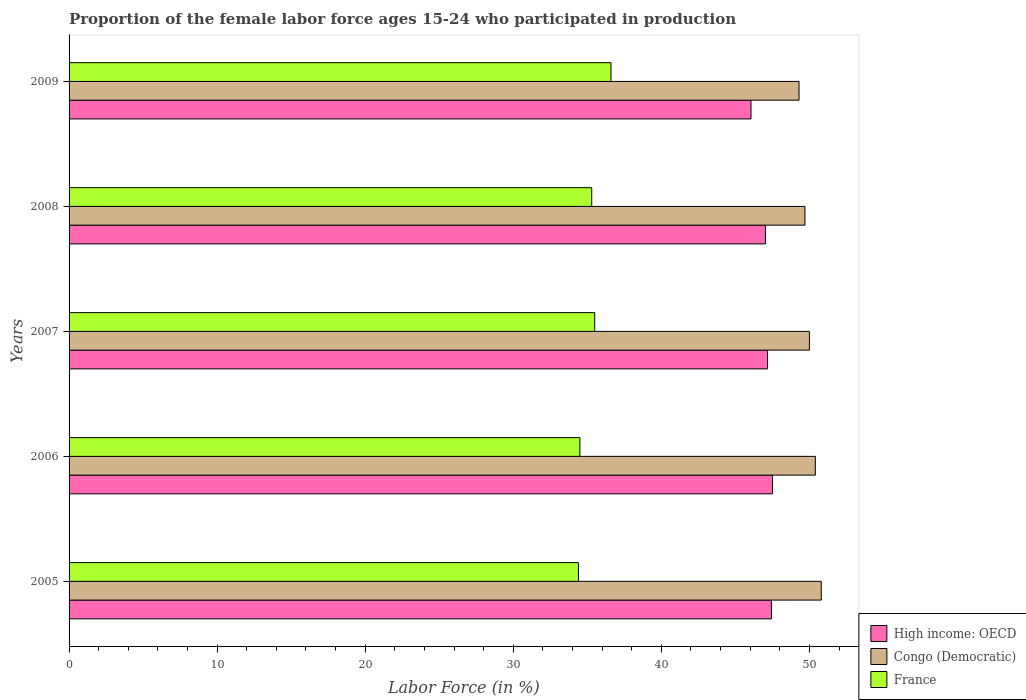How many different coloured bars are there?
Make the answer very short. 3. Are the number of bars per tick equal to the number of legend labels?
Give a very brief answer. Yes. How many bars are there on the 3rd tick from the top?
Provide a short and direct response. 3. How many bars are there on the 5th tick from the bottom?
Keep it short and to the point. 3. What is the label of the 1st group of bars from the top?
Provide a succinct answer. 2009. What is the proportion of the female labor force who participated in production in France in 2005?
Keep it short and to the point. 34.4. Across all years, what is the maximum proportion of the female labor force who participated in production in Congo (Democratic)?
Your answer should be compact. 50.8. Across all years, what is the minimum proportion of the female labor force who participated in production in Congo (Democratic)?
Provide a short and direct response. 49.3. In which year was the proportion of the female labor force who participated in production in France minimum?
Ensure brevity in your answer.  2005. What is the total proportion of the female labor force who participated in production in France in the graph?
Ensure brevity in your answer.  176.3. What is the difference between the proportion of the female labor force who participated in production in France in 2005 and that in 2009?
Your answer should be compact. -2.2. What is the difference between the proportion of the female labor force who participated in production in High income: OECD in 2006 and the proportion of the female labor force who participated in production in Congo (Democratic) in 2007?
Provide a short and direct response. -2.49. What is the average proportion of the female labor force who participated in production in High income: OECD per year?
Give a very brief answer. 47.04. In the year 2008, what is the difference between the proportion of the female labor force who participated in production in Congo (Democratic) and proportion of the female labor force who participated in production in France?
Your response must be concise. 14.4. In how many years, is the proportion of the female labor force who participated in production in Congo (Democratic) greater than 16 %?
Provide a succinct answer. 5. What is the ratio of the proportion of the female labor force who participated in production in Congo (Democratic) in 2007 to that in 2008?
Provide a short and direct response. 1.01. Is the proportion of the female labor force who participated in production in Congo (Democratic) in 2007 less than that in 2008?
Make the answer very short. No. What is the difference between the highest and the second highest proportion of the female labor force who participated in production in France?
Offer a terse response. 1.1. What is the difference between the highest and the lowest proportion of the female labor force who participated in production in High income: OECD?
Provide a succinct answer. 1.45. What does the 3rd bar from the bottom in 2006 represents?
Offer a very short reply. France. Are all the bars in the graph horizontal?
Make the answer very short. Yes. How many years are there in the graph?
Ensure brevity in your answer.  5. Where does the legend appear in the graph?
Your answer should be very brief. Bottom right. How many legend labels are there?
Your answer should be very brief. 3. How are the legend labels stacked?
Offer a terse response. Vertical. What is the title of the graph?
Keep it short and to the point. Proportion of the female labor force ages 15-24 who participated in production. Does "Singapore" appear as one of the legend labels in the graph?
Your response must be concise. No. What is the Labor Force (in %) of High income: OECD in 2005?
Your response must be concise. 47.44. What is the Labor Force (in %) of Congo (Democratic) in 2005?
Offer a terse response. 50.8. What is the Labor Force (in %) in France in 2005?
Provide a succinct answer. 34.4. What is the Labor Force (in %) in High income: OECD in 2006?
Offer a terse response. 47.51. What is the Labor Force (in %) of Congo (Democratic) in 2006?
Make the answer very short. 50.4. What is the Labor Force (in %) in France in 2006?
Give a very brief answer. 34.5. What is the Labor Force (in %) in High income: OECD in 2007?
Your answer should be compact. 47.17. What is the Labor Force (in %) of Congo (Democratic) in 2007?
Make the answer very short. 50. What is the Labor Force (in %) of France in 2007?
Your response must be concise. 35.5. What is the Labor Force (in %) in High income: OECD in 2008?
Your answer should be very brief. 47.03. What is the Labor Force (in %) of Congo (Democratic) in 2008?
Your answer should be very brief. 49.7. What is the Labor Force (in %) of France in 2008?
Provide a succinct answer. 35.3. What is the Labor Force (in %) in High income: OECD in 2009?
Offer a very short reply. 46.06. What is the Labor Force (in %) of Congo (Democratic) in 2009?
Your response must be concise. 49.3. What is the Labor Force (in %) of France in 2009?
Your answer should be compact. 36.6. Across all years, what is the maximum Labor Force (in %) of High income: OECD?
Provide a short and direct response. 47.51. Across all years, what is the maximum Labor Force (in %) in Congo (Democratic)?
Keep it short and to the point. 50.8. Across all years, what is the maximum Labor Force (in %) of France?
Offer a very short reply. 36.6. Across all years, what is the minimum Labor Force (in %) of High income: OECD?
Your answer should be very brief. 46.06. Across all years, what is the minimum Labor Force (in %) of Congo (Democratic)?
Your response must be concise. 49.3. Across all years, what is the minimum Labor Force (in %) of France?
Ensure brevity in your answer.  34.4. What is the total Labor Force (in %) in High income: OECD in the graph?
Your answer should be compact. 235.2. What is the total Labor Force (in %) of Congo (Democratic) in the graph?
Keep it short and to the point. 250.2. What is the total Labor Force (in %) of France in the graph?
Ensure brevity in your answer.  176.3. What is the difference between the Labor Force (in %) in High income: OECD in 2005 and that in 2006?
Offer a very short reply. -0.07. What is the difference between the Labor Force (in %) in Congo (Democratic) in 2005 and that in 2006?
Ensure brevity in your answer.  0.4. What is the difference between the Labor Force (in %) in France in 2005 and that in 2006?
Your answer should be compact. -0.1. What is the difference between the Labor Force (in %) of High income: OECD in 2005 and that in 2007?
Offer a terse response. 0.26. What is the difference between the Labor Force (in %) in High income: OECD in 2005 and that in 2008?
Your answer should be very brief. 0.4. What is the difference between the Labor Force (in %) of Congo (Democratic) in 2005 and that in 2008?
Offer a very short reply. 1.1. What is the difference between the Labor Force (in %) of France in 2005 and that in 2008?
Keep it short and to the point. -0.9. What is the difference between the Labor Force (in %) of High income: OECD in 2005 and that in 2009?
Your answer should be very brief. 1.38. What is the difference between the Labor Force (in %) of High income: OECD in 2006 and that in 2007?
Give a very brief answer. 0.33. What is the difference between the Labor Force (in %) of Congo (Democratic) in 2006 and that in 2007?
Keep it short and to the point. 0.4. What is the difference between the Labor Force (in %) of France in 2006 and that in 2007?
Make the answer very short. -1. What is the difference between the Labor Force (in %) in High income: OECD in 2006 and that in 2008?
Offer a terse response. 0.47. What is the difference between the Labor Force (in %) in France in 2006 and that in 2008?
Offer a terse response. -0.8. What is the difference between the Labor Force (in %) of High income: OECD in 2006 and that in 2009?
Your answer should be very brief. 1.45. What is the difference between the Labor Force (in %) of Congo (Democratic) in 2006 and that in 2009?
Make the answer very short. 1.1. What is the difference between the Labor Force (in %) of France in 2006 and that in 2009?
Your response must be concise. -2.1. What is the difference between the Labor Force (in %) in High income: OECD in 2007 and that in 2008?
Make the answer very short. 0.14. What is the difference between the Labor Force (in %) of Congo (Democratic) in 2007 and that in 2008?
Offer a terse response. 0.3. What is the difference between the Labor Force (in %) in France in 2007 and that in 2008?
Ensure brevity in your answer.  0.2. What is the difference between the Labor Force (in %) in High income: OECD in 2007 and that in 2009?
Provide a succinct answer. 1.12. What is the difference between the Labor Force (in %) in High income: OECD in 2008 and that in 2009?
Make the answer very short. 0.98. What is the difference between the Labor Force (in %) of Congo (Democratic) in 2008 and that in 2009?
Provide a succinct answer. 0.4. What is the difference between the Labor Force (in %) in High income: OECD in 2005 and the Labor Force (in %) in Congo (Democratic) in 2006?
Give a very brief answer. -2.96. What is the difference between the Labor Force (in %) of High income: OECD in 2005 and the Labor Force (in %) of France in 2006?
Your answer should be very brief. 12.94. What is the difference between the Labor Force (in %) in Congo (Democratic) in 2005 and the Labor Force (in %) in France in 2006?
Your answer should be compact. 16.3. What is the difference between the Labor Force (in %) of High income: OECD in 2005 and the Labor Force (in %) of Congo (Democratic) in 2007?
Give a very brief answer. -2.56. What is the difference between the Labor Force (in %) of High income: OECD in 2005 and the Labor Force (in %) of France in 2007?
Offer a terse response. 11.94. What is the difference between the Labor Force (in %) in High income: OECD in 2005 and the Labor Force (in %) in Congo (Democratic) in 2008?
Ensure brevity in your answer.  -2.26. What is the difference between the Labor Force (in %) of High income: OECD in 2005 and the Labor Force (in %) of France in 2008?
Provide a short and direct response. 12.14. What is the difference between the Labor Force (in %) of Congo (Democratic) in 2005 and the Labor Force (in %) of France in 2008?
Make the answer very short. 15.5. What is the difference between the Labor Force (in %) of High income: OECD in 2005 and the Labor Force (in %) of Congo (Democratic) in 2009?
Provide a short and direct response. -1.86. What is the difference between the Labor Force (in %) of High income: OECD in 2005 and the Labor Force (in %) of France in 2009?
Your answer should be compact. 10.84. What is the difference between the Labor Force (in %) in Congo (Democratic) in 2005 and the Labor Force (in %) in France in 2009?
Your answer should be compact. 14.2. What is the difference between the Labor Force (in %) of High income: OECD in 2006 and the Labor Force (in %) of Congo (Democratic) in 2007?
Provide a succinct answer. -2.49. What is the difference between the Labor Force (in %) in High income: OECD in 2006 and the Labor Force (in %) in France in 2007?
Your answer should be compact. 12.01. What is the difference between the Labor Force (in %) of Congo (Democratic) in 2006 and the Labor Force (in %) of France in 2007?
Your answer should be compact. 14.9. What is the difference between the Labor Force (in %) of High income: OECD in 2006 and the Labor Force (in %) of Congo (Democratic) in 2008?
Make the answer very short. -2.19. What is the difference between the Labor Force (in %) of High income: OECD in 2006 and the Labor Force (in %) of France in 2008?
Ensure brevity in your answer.  12.21. What is the difference between the Labor Force (in %) of Congo (Democratic) in 2006 and the Labor Force (in %) of France in 2008?
Provide a short and direct response. 15.1. What is the difference between the Labor Force (in %) of High income: OECD in 2006 and the Labor Force (in %) of Congo (Democratic) in 2009?
Your answer should be compact. -1.79. What is the difference between the Labor Force (in %) of High income: OECD in 2006 and the Labor Force (in %) of France in 2009?
Make the answer very short. 10.91. What is the difference between the Labor Force (in %) of High income: OECD in 2007 and the Labor Force (in %) of Congo (Democratic) in 2008?
Offer a very short reply. -2.53. What is the difference between the Labor Force (in %) in High income: OECD in 2007 and the Labor Force (in %) in France in 2008?
Your response must be concise. 11.87. What is the difference between the Labor Force (in %) in Congo (Democratic) in 2007 and the Labor Force (in %) in France in 2008?
Offer a terse response. 14.7. What is the difference between the Labor Force (in %) of High income: OECD in 2007 and the Labor Force (in %) of Congo (Democratic) in 2009?
Your response must be concise. -2.13. What is the difference between the Labor Force (in %) in High income: OECD in 2007 and the Labor Force (in %) in France in 2009?
Offer a terse response. 10.57. What is the difference between the Labor Force (in %) in High income: OECD in 2008 and the Labor Force (in %) in Congo (Democratic) in 2009?
Make the answer very short. -2.27. What is the difference between the Labor Force (in %) of High income: OECD in 2008 and the Labor Force (in %) of France in 2009?
Provide a short and direct response. 10.43. What is the difference between the Labor Force (in %) in Congo (Democratic) in 2008 and the Labor Force (in %) in France in 2009?
Keep it short and to the point. 13.1. What is the average Labor Force (in %) of High income: OECD per year?
Provide a succinct answer. 47.04. What is the average Labor Force (in %) of Congo (Democratic) per year?
Keep it short and to the point. 50.04. What is the average Labor Force (in %) of France per year?
Make the answer very short. 35.26. In the year 2005, what is the difference between the Labor Force (in %) of High income: OECD and Labor Force (in %) of Congo (Democratic)?
Ensure brevity in your answer.  -3.36. In the year 2005, what is the difference between the Labor Force (in %) of High income: OECD and Labor Force (in %) of France?
Offer a terse response. 13.04. In the year 2006, what is the difference between the Labor Force (in %) in High income: OECD and Labor Force (in %) in Congo (Democratic)?
Provide a succinct answer. -2.89. In the year 2006, what is the difference between the Labor Force (in %) of High income: OECD and Labor Force (in %) of France?
Give a very brief answer. 13.01. In the year 2006, what is the difference between the Labor Force (in %) in Congo (Democratic) and Labor Force (in %) in France?
Ensure brevity in your answer.  15.9. In the year 2007, what is the difference between the Labor Force (in %) in High income: OECD and Labor Force (in %) in Congo (Democratic)?
Offer a terse response. -2.83. In the year 2007, what is the difference between the Labor Force (in %) of High income: OECD and Labor Force (in %) of France?
Your answer should be very brief. 11.67. In the year 2008, what is the difference between the Labor Force (in %) in High income: OECD and Labor Force (in %) in Congo (Democratic)?
Make the answer very short. -2.67. In the year 2008, what is the difference between the Labor Force (in %) in High income: OECD and Labor Force (in %) in France?
Give a very brief answer. 11.73. In the year 2009, what is the difference between the Labor Force (in %) of High income: OECD and Labor Force (in %) of Congo (Democratic)?
Your answer should be very brief. -3.24. In the year 2009, what is the difference between the Labor Force (in %) in High income: OECD and Labor Force (in %) in France?
Your answer should be very brief. 9.46. In the year 2009, what is the difference between the Labor Force (in %) of Congo (Democratic) and Labor Force (in %) of France?
Offer a terse response. 12.7. What is the ratio of the Labor Force (in %) of Congo (Democratic) in 2005 to that in 2006?
Give a very brief answer. 1.01. What is the ratio of the Labor Force (in %) of France in 2005 to that in 2006?
Your answer should be compact. 1. What is the ratio of the Labor Force (in %) of High income: OECD in 2005 to that in 2007?
Your answer should be very brief. 1.01. What is the ratio of the Labor Force (in %) in France in 2005 to that in 2007?
Your response must be concise. 0.97. What is the ratio of the Labor Force (in %) of High income: OECD in 2005 to that in 2008?
Make the answer very short. 1.01. What is the ratio of the Labor Force (in %) of Congo (Democratic) in 2005 to that in 2008?
Offer a very short reply. 1.02. What is the ratio of the Labor Force (in %) in France in 2005 to that in 2008?
Ensure brevity in your answer.  0.97. What is the ratio of the Labor Force (in %) in High income: OECD in 2005 to that in 2009?
Offer a terse response. 1.03. What is the ratio of the Labor Force (in %) in Congo (Democratic) in 2005 to that in 2009?
Provide a succinct answer. 1.03. What is the ratio of the Labor Force (in %) in France in 2005 to that in 2009?
Give a very brief answer. 0.94. What is the ratio of the Labor Force (in %) in High income: OECD in 2006 to that in 2007?
Offer a terse response. 1.01. What is the ratio of the Labor Force (in %) in France in 2006 to that in 2007?
Your response must be concise. 0.97. What is the ratio of the Labor Force (in %) of Congo (Democratic) in 2006 to that in 2008?
Make the answer very short. 1.01. What is the ratio of the Labor Force (in %) in France in 2006 to that in 2008?
Ensure brevity in your answer.  0.98. What is the ratio of the Labor Force (in %) in High income: OECD in 2006 to that in 2009?
Make the answer very short. 1.03. What is the ratio of the Labor Force (in %) in Congo (Democratic) in 2006 to that in 2009?
Provide a short and direct response. 1.02. What is the ratio of the Labor Force (in %) in France in 2006 to that in 2009?
Your answer should be compact. 0.94. What is the ratio of the Labor Force (in %) in High income: OECD in 2007 to that in 2008?
Provide a succinct answer. 1. What is the ratio of the Labor Force (in %) of Congo (Democratic) in 2007 to that in 2008?
Make the answer very short. 1.01. What is the ratio of the Labor Force (in %) in High income: OECD in 2007 to that in 2009?
Your answer should be very brief. 1.02. What is the ratio of the Labor Force (in %) in Congo (Democratic) in 2007 to that in 2009?
Provide a short and direct response. 1.01. What is the ratio of the Labor Force (in %) in France in 2007 to that in 2009?
Ensure brevity in your answer.  0.97. What is the ratio of the Labor Force (in %) in High income: OECD in 2008 to that in 2009?
Offer a terse response. 1.02. What is the ratio of the Labor Force (in %) in Congo (Democratic) in 2008 to that in 2009?
Your response must be concise. 1.01. What is the ratio of the Labor Force (in %) in France in 2008 to that in 2009?
Your answer should be very brief. 0.96. What is the difference between the highest and the second highest Labor Force (in %) in High income: OECD?
Give a very brief answer. 0.07. What is the difference between the highest and the second highest Labor Force (in %) of France?
Offer a terse response. 1.1. What is the difference between the highest and the lowest Labor Force (in %) of High income: OECD?
Your answer should be very brief. 1.45. What is the difference between the highest and the lowest Labor Force (in %) in France?
Keep it short and to the point. 2.2. 